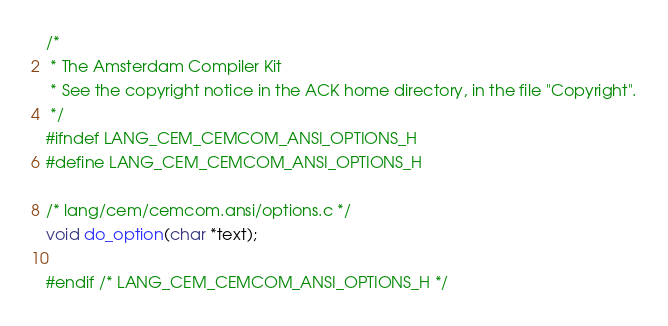<code> <loc_0><loc_0><loc_500><loc_500><_C_>/*
 * The Amsterdam Compiler Kit
 * See the copyright notice in the ACK home directory, in the file "Copyright".
 */
#ifndef LANG_CEM_CEMCOM_ANSI_OPTIONS_H
#define LANG_CEM_CEMCOM_ANSI_OPTIONS_H

/* lang/cem/cemcom.ansi/options.c */
void do_option(char *text);

#endif /* LANG_CEM_CEMCOM_ANSI_OPTIONS_H */

</code> 